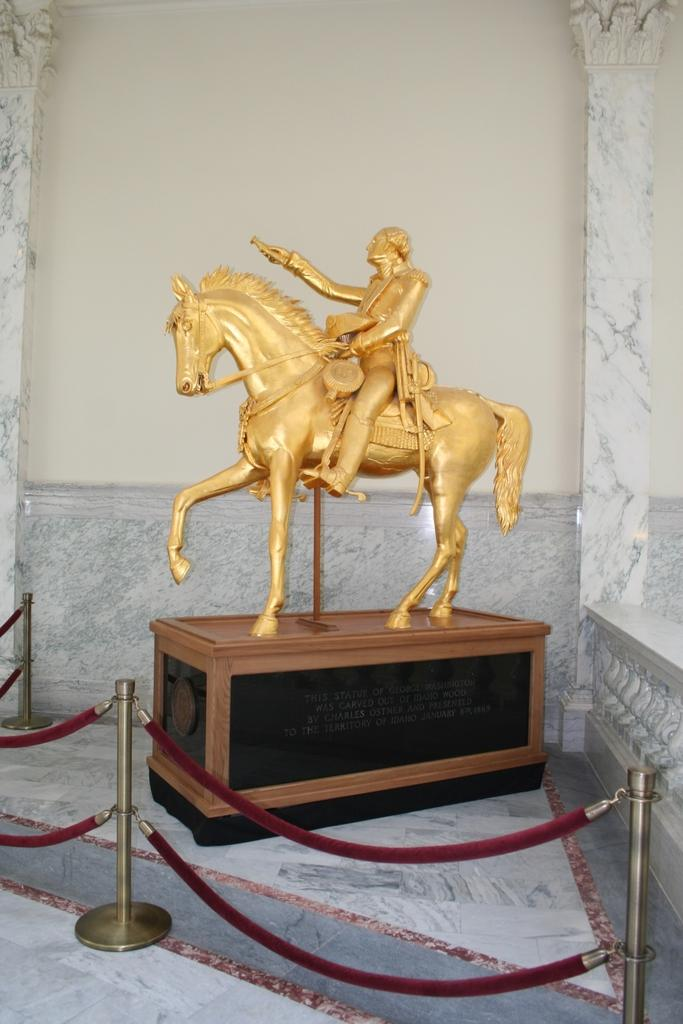What is the main subject of the image? There is a statue of a man riding a horse in the image. What is the statue standing on? The statue is on a wooden block. Is the statue enclosed by any structure? Yes, the statue is inside a fence. What is visible behind the statue? There is a wall behind the statue. Where is the kitty sitting in the image? There is no kitty present in the image. What type of lamp is illuminating the statue in the image? There is no lamp present in the image; the statue is not illuminated. 